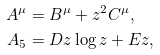<formula> <loc_0><loc_0><loc_500><loc_500>A ^ { \mu } & = B ^ { \mu } + z ^ { 2 } C ^ { \mu } , \\ A _ { 5 } & = D z \log { z } + E z ,</formula> 